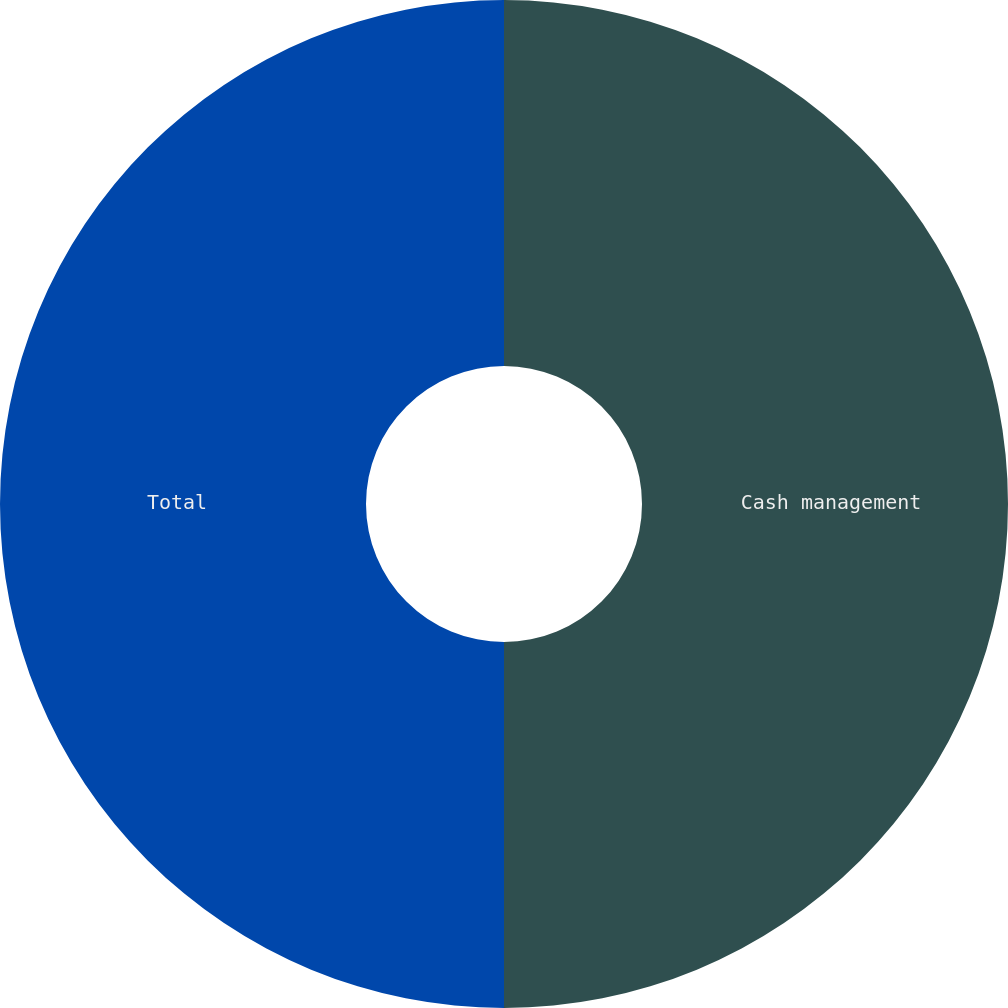Convert chart. <chart><loc_0><loc_0><loc_500><loc_500><pie_chart><fcel>Cash management<fcel>Total<nl><fcel>50.0%<fcel>50.0%<nl></chart> 